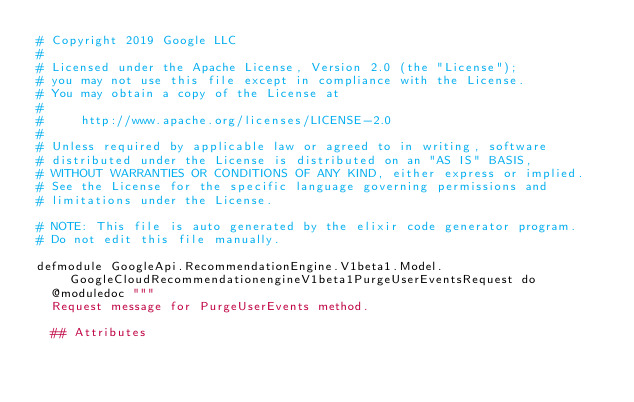Convert code to text. <code><loc_0><loc_0><loc_500><loc_500><_Elixir_># Copyright 2019 Google LLC
#
# Licensed under the Apache License, Version 2.0 (the "License");
# you may not use this file except in compliance with the License.
# You may obtain a copy of the License at
#
#     http://www.apache.org/licenses/LICENSE-2.0
#
# Unless required by applicable law or agreed to in writing, software
# distributed under the License is distributed on an "AS IS" BASIS,
# WITHOUT WARRANTIES OR CONDITIONS OF ANY KIND, either express or implied.
# See the License for the specific language governing permissions and
# limitations under the License.

# NOTE: This file is auto generated by the elixir code generator program.
# Do not edit this file manually.

defmodule GoogleApi.RecommendationEngine.V1beta1.Model.GoogleCloudRecommendationengineV1beta1PurgeUserEventsRequest do
  @moduledoc """
  Request message for PurgeUserEvents method.

  ## Attributes
</code> 